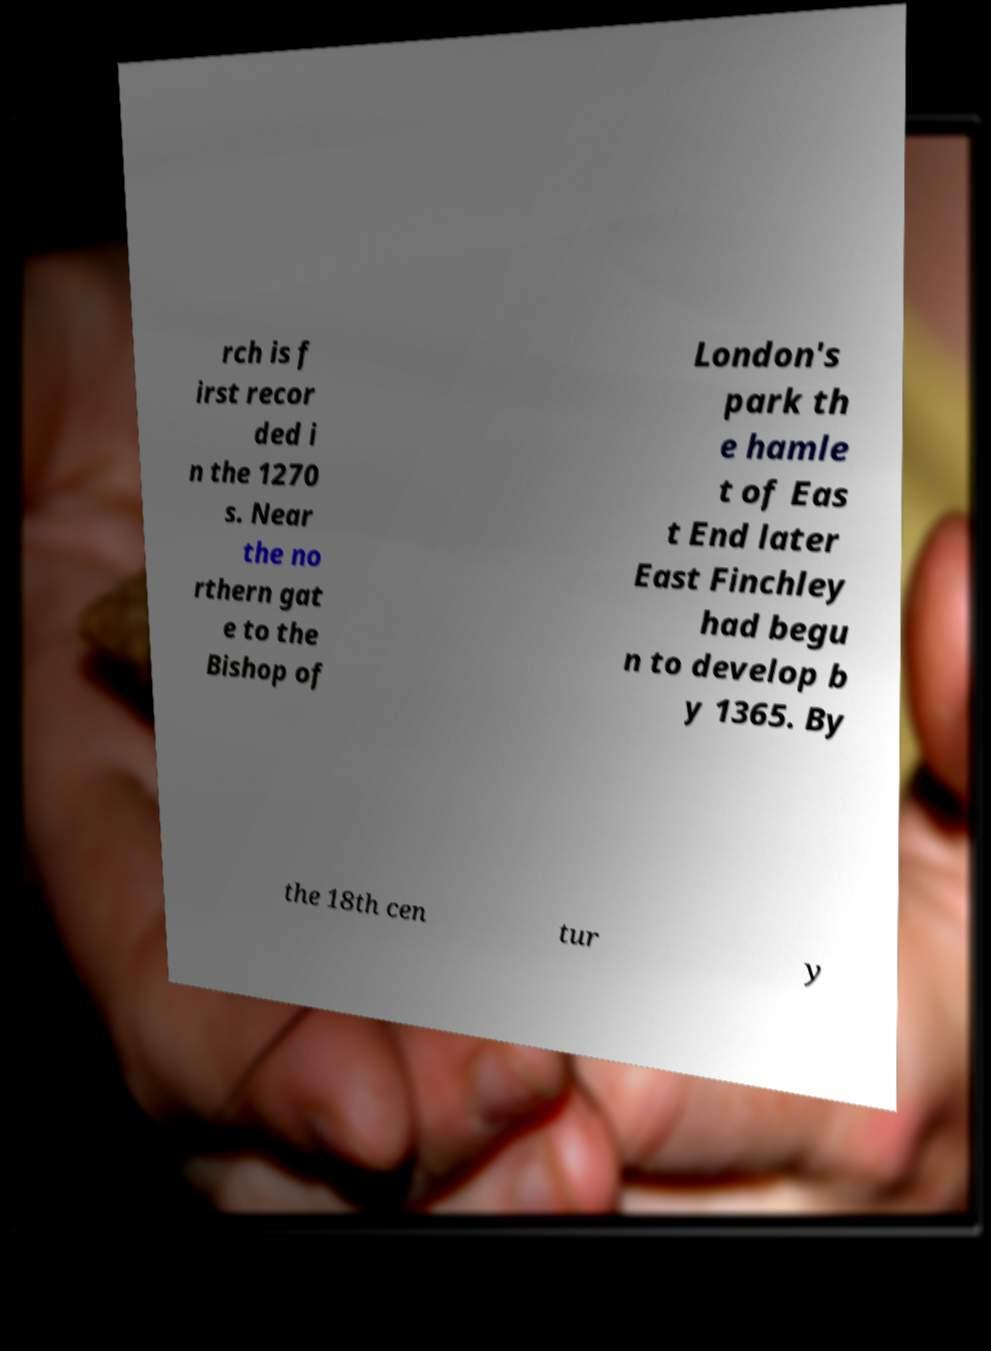I need the written content from this picture converted into text. Can you do that? rch is f irst recor ded i n the 1270 s. Near the no rthern gat e to the Bishop of London's park th e hamle t of Eas t End later East Finchley had begu n to develop b y 1365. By the 18th cen tur y 